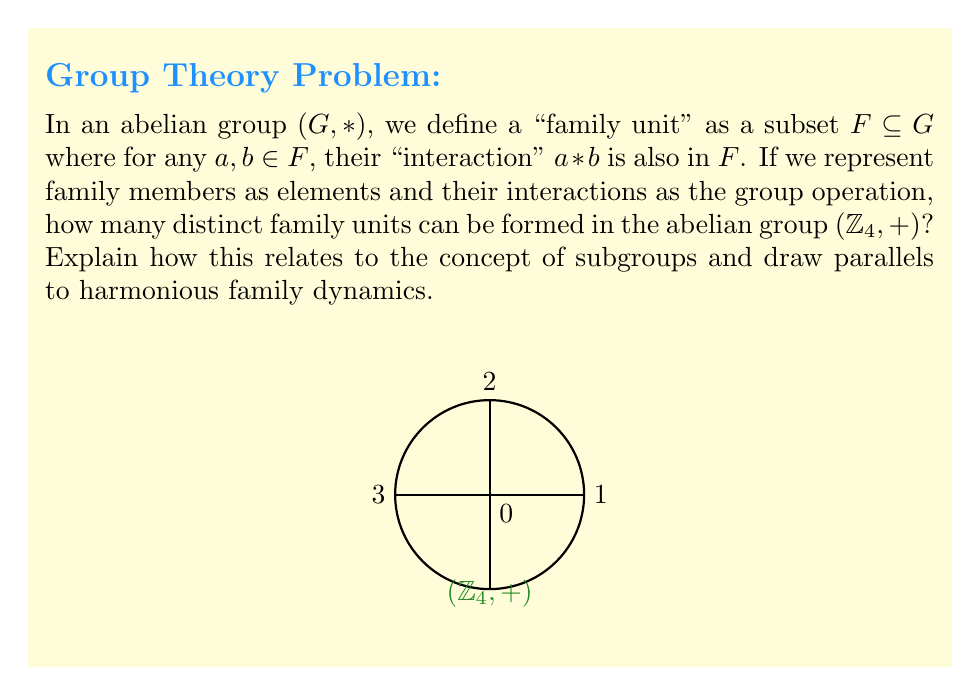Show me your answer to this math problem. Let's approach this step-by-step:

1) First, recall that $(\mathbb{Z}_4, +)$ is the group of integers modulo 4 under addition. Its elements are $\{0, 1, 2, 3\}$.

2) In an abelian group, the "family units" we're looking for are actually subgroups. This is because:
   - They contain the identity element (representing harmony or neutrality in family dynamics)
   - They are closed under the group operation (interactions within the family stay within the family)
   - Every element has an inverse (every action can be counterbalanced)

3) To find all subgroups of $(\mathbb{Z}_4, +)$, we need to check which subsets are closed under addition modulo 4:

   - $\{0\}$ is always a subgroup (the trivial subgroup)
   - $\{0, 2\}$ is a subgroup (2 + 2 ≡ 0 mod 4)
   - $\{0, 1, 2, 3\}$ is the entire group

4) There are no other subgroups because:
   - $\{0, 1\}$ is not closed (1 + 1 = 2)
   - $\{0, 3\}$ is not closed (3 + 3 = 2)
   - Any subset containing 1 or 3 will generate the entire group

5) Therefore, there are 3 distinct "family units" or subgroups in $(\mathbb{Z}_4, +)$.

Relating this to family dynamics:
- The trivial subgroup $\{0\}$ could represent individual autonomy or self-reliance.
- $\{0, 2\}$ could represent a balanced partnership or a parent-child relationship.
- The entire group $\{0, 1, 2, 3\}$ represents the full family unit working together harmoniously.

The abelian nature of the group ensures that interactions are commutative, mirroring the idea of mutual respect and equality in family relationships.
Answer: 3 subgroups 